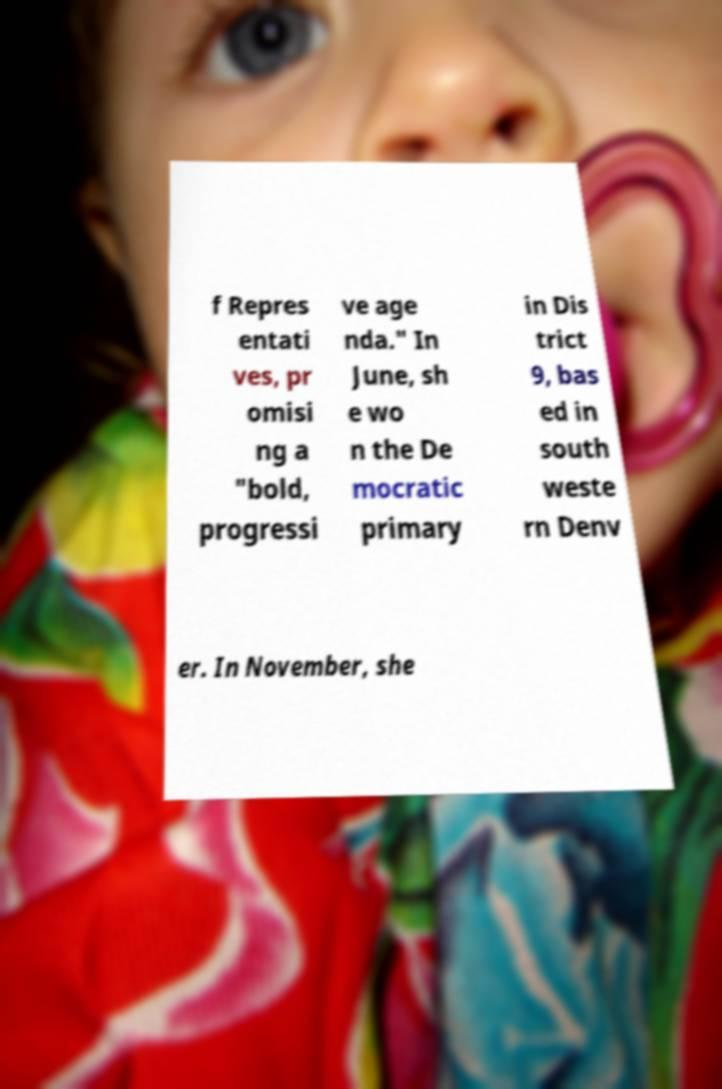There's text embedded in this image that I need extracted. Can you transcribe it verbatim? f Repres entati ves, pr omisi ng a "bold, progressi ve age nda." In June, sh e wo n the De mocratic primary in Dis trict 9, bas ed in south weste rn Denv er. In November, she 